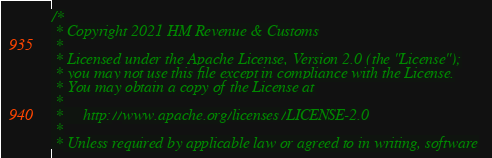<code> <loc_0><loc_0><loc_500><loc_500><_Scala_>/*
 * Copyright 2021 HM Revenue & Customs
 *
 * Licensed under the Apache License, Version 2.0 (the "License");
 * you may not use this file except in compliance with the License.
 * You may obtain a copy of the License at
 *
 *     http://www.apache.org/licenses/LICENSE-2.0
 *
 * Unless required by applicable law or agreed to in writing, software</code> 